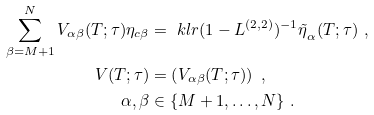<formula> <loc_0><loc_0><loc_500><loc_500>\sum ^ { N } _ { \beta = M + 1 } V _ { \alpha \beta } ( T ; \tau ) \eta _ { c \beta } & = \ k l r { ( 1 - L ^ { ( 2 , 2 ) } ) ^ { - 1 } \tilde { \eta } } _ { \alpha } ( T ; \tau ) \ , \\ V ( T ; \tau ) & = \left ( V _ { \alpha \beta } ( T ; \tau ) \right ) \ , \\ \alpha , \beta & \in \{ M + 1 , \dots , N \} \ .</formula> 